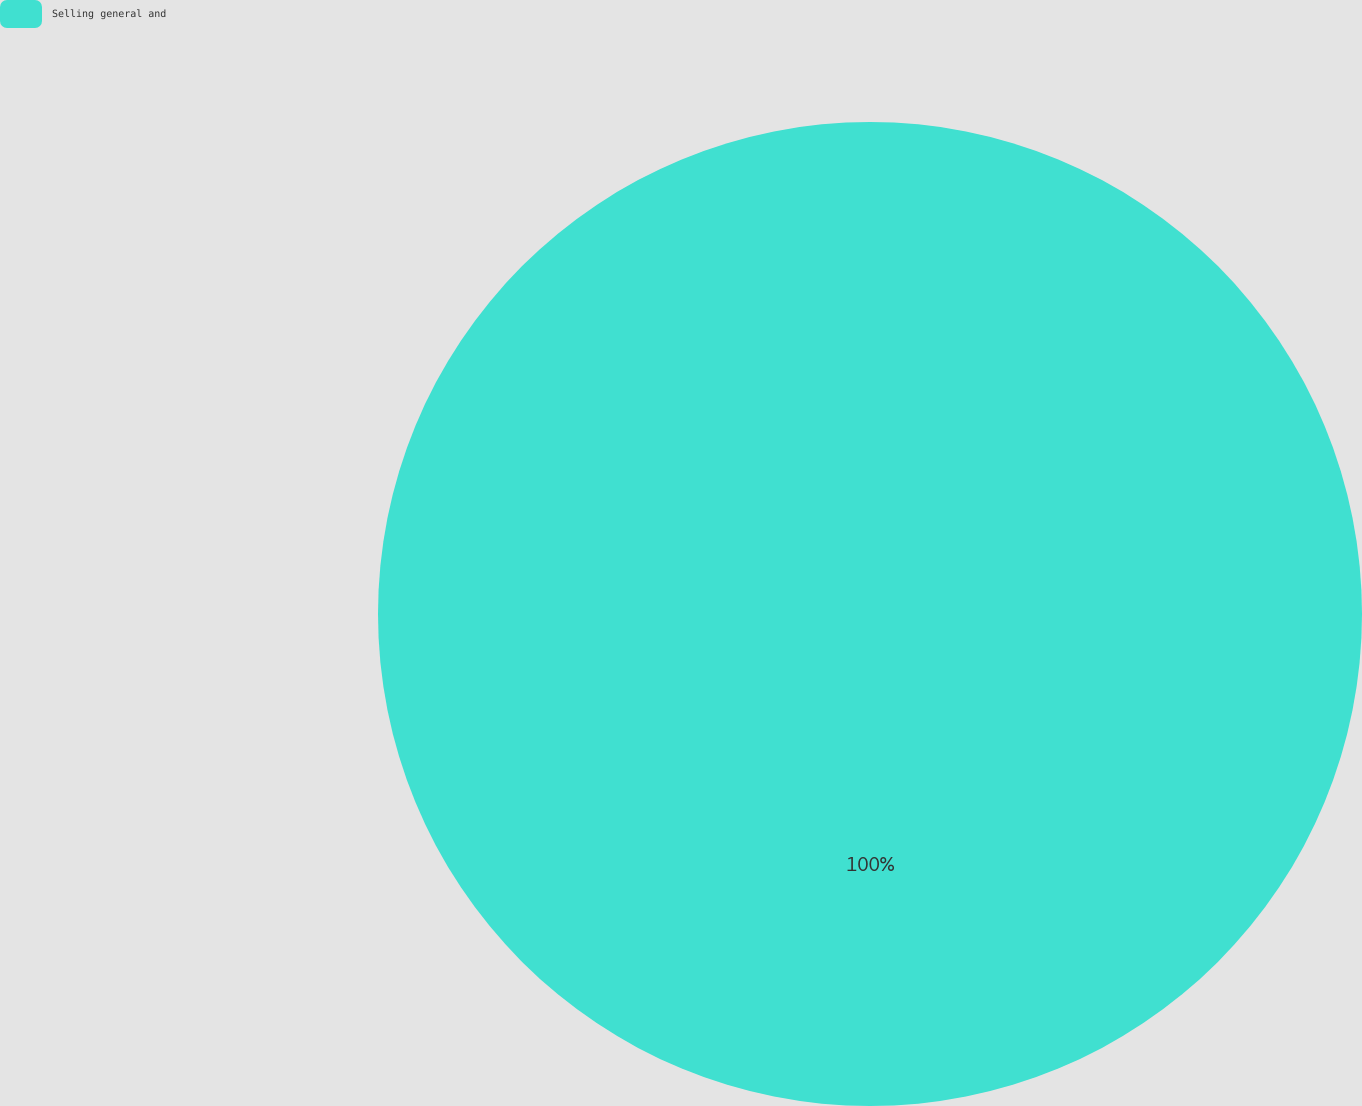Convert chart to OTSL. <chart><loc_0><loc_0><loc_500><loc_500><pie_chart><fcel>Selling general and<nl><fcel>100.0%<nl></chart> 